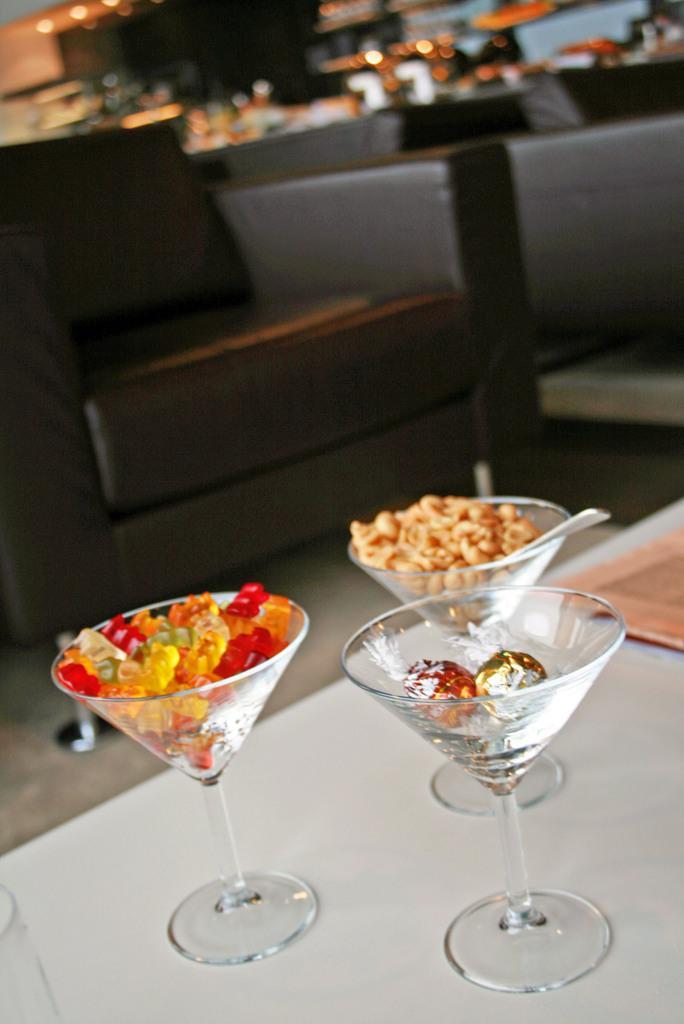Could you give a brief overview of what you see in this image? In this picture we can observe some glasses placed on the white color table. We can observe brown color sofa. The background is completely blurred. 